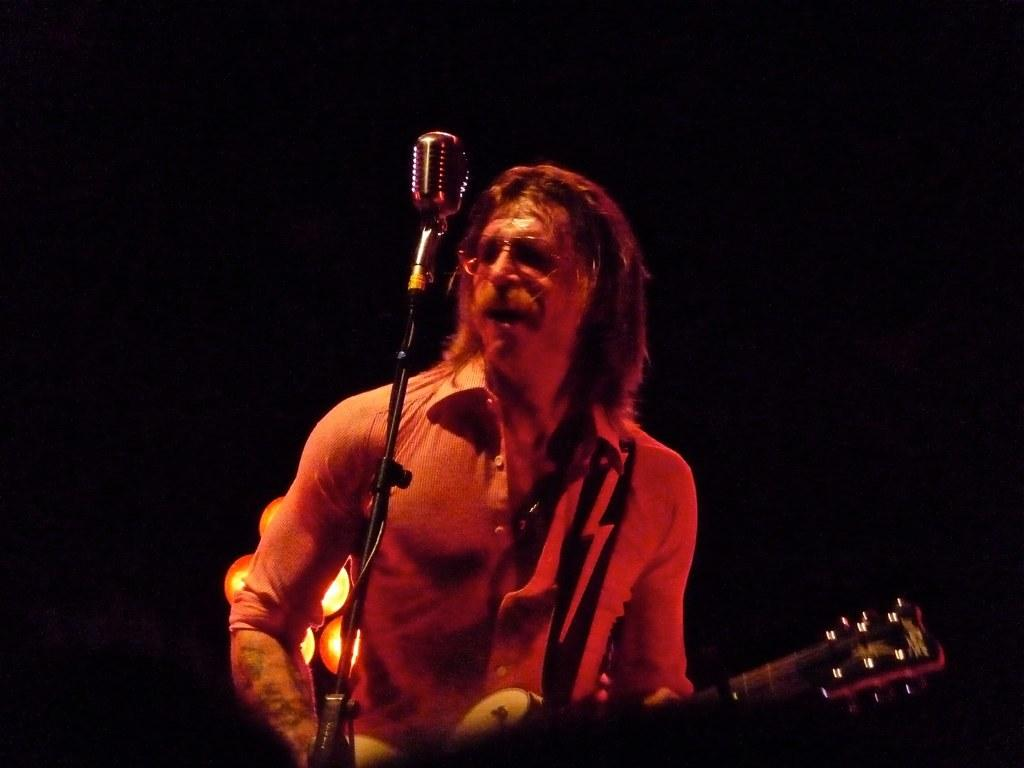What is the person in the image doing with their hands? The person is holding a guitar. What activity is the person engaged in? The person is singing a song. What can be observed about the person's mouth? The person's mouth is open. What accessory is the person wearing? The person is wearing spectacles. What color is the governor's shirt in the image? There is no governor present in the image, so it is not possible to determine the color of their shirt. 